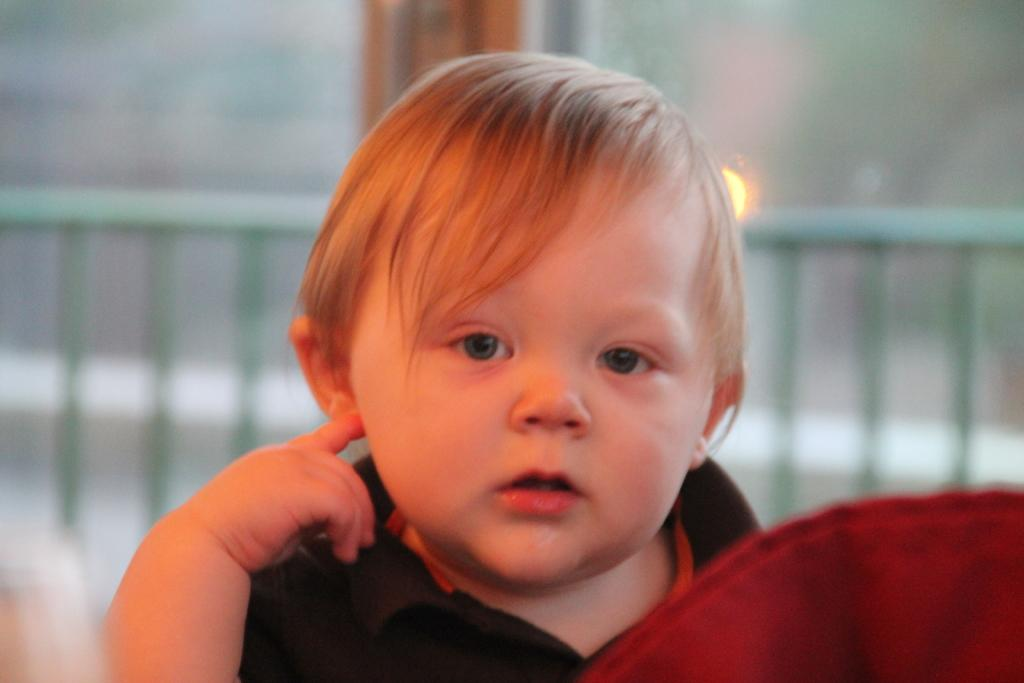What is the main subject of the image? The main subject of the image is a kid. What can be seen in the background of the image? There are metal rods in the background of the image. What type of cream is the kid wearing on their vest in the image? There is no mention of cream or a vest in the image, so it cannot be determined if the kid is wearing a vest or any cream. 